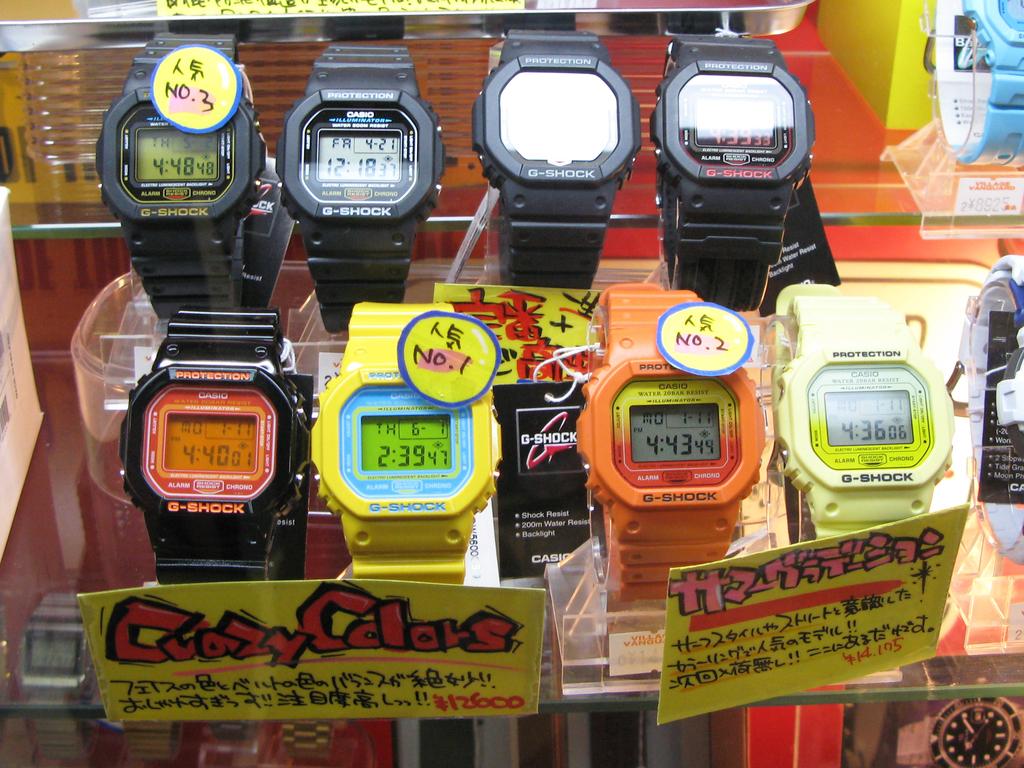What brand of watches are these?
Give a very brief answer. G-shock. What time is on the orange watch?
Ensure brevity in your answer.  4:43. 